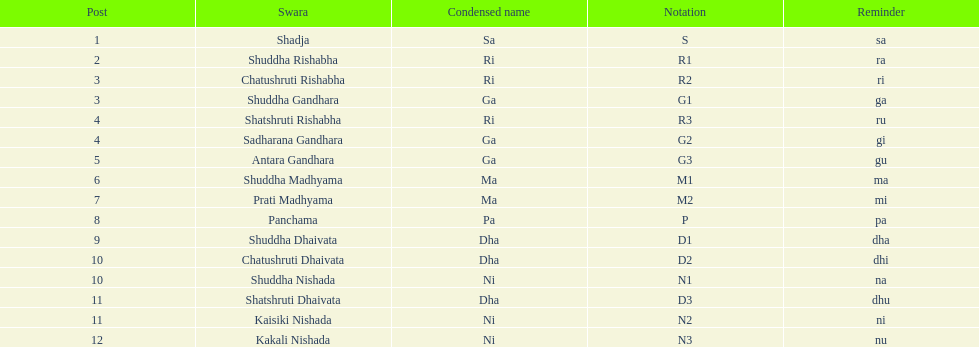Other than m1 how many notations have "1" in them? 4. 